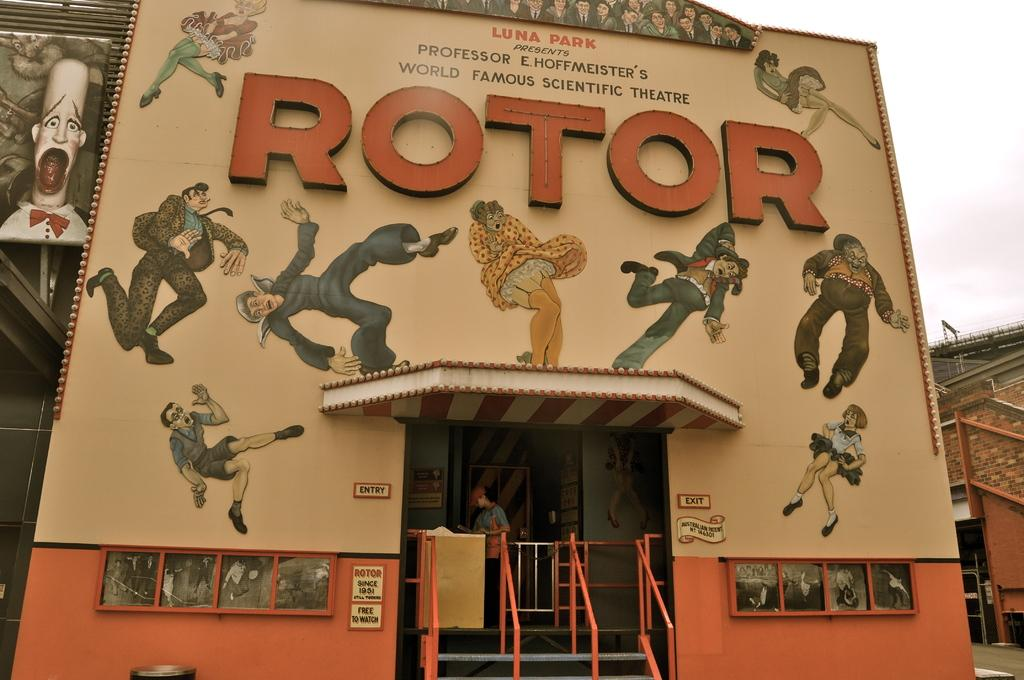What structure is depicted in the image? There is a building in the image. Who or what can be seen at the bottom of the image? There is a man at the bottom of the image. What architectural feature is present at the bottom of the image? There are stairs at the bottom of the image. What is visible at the top of the image? The sky is visible at the top of the image. What type of fiction is the man reading at the bottom of the image? There is no indication in the image that the man is reading any fiction. What button might the man be using to control the building's functions? There is no button present in the image, and the man is not shown controlling any building functions. 